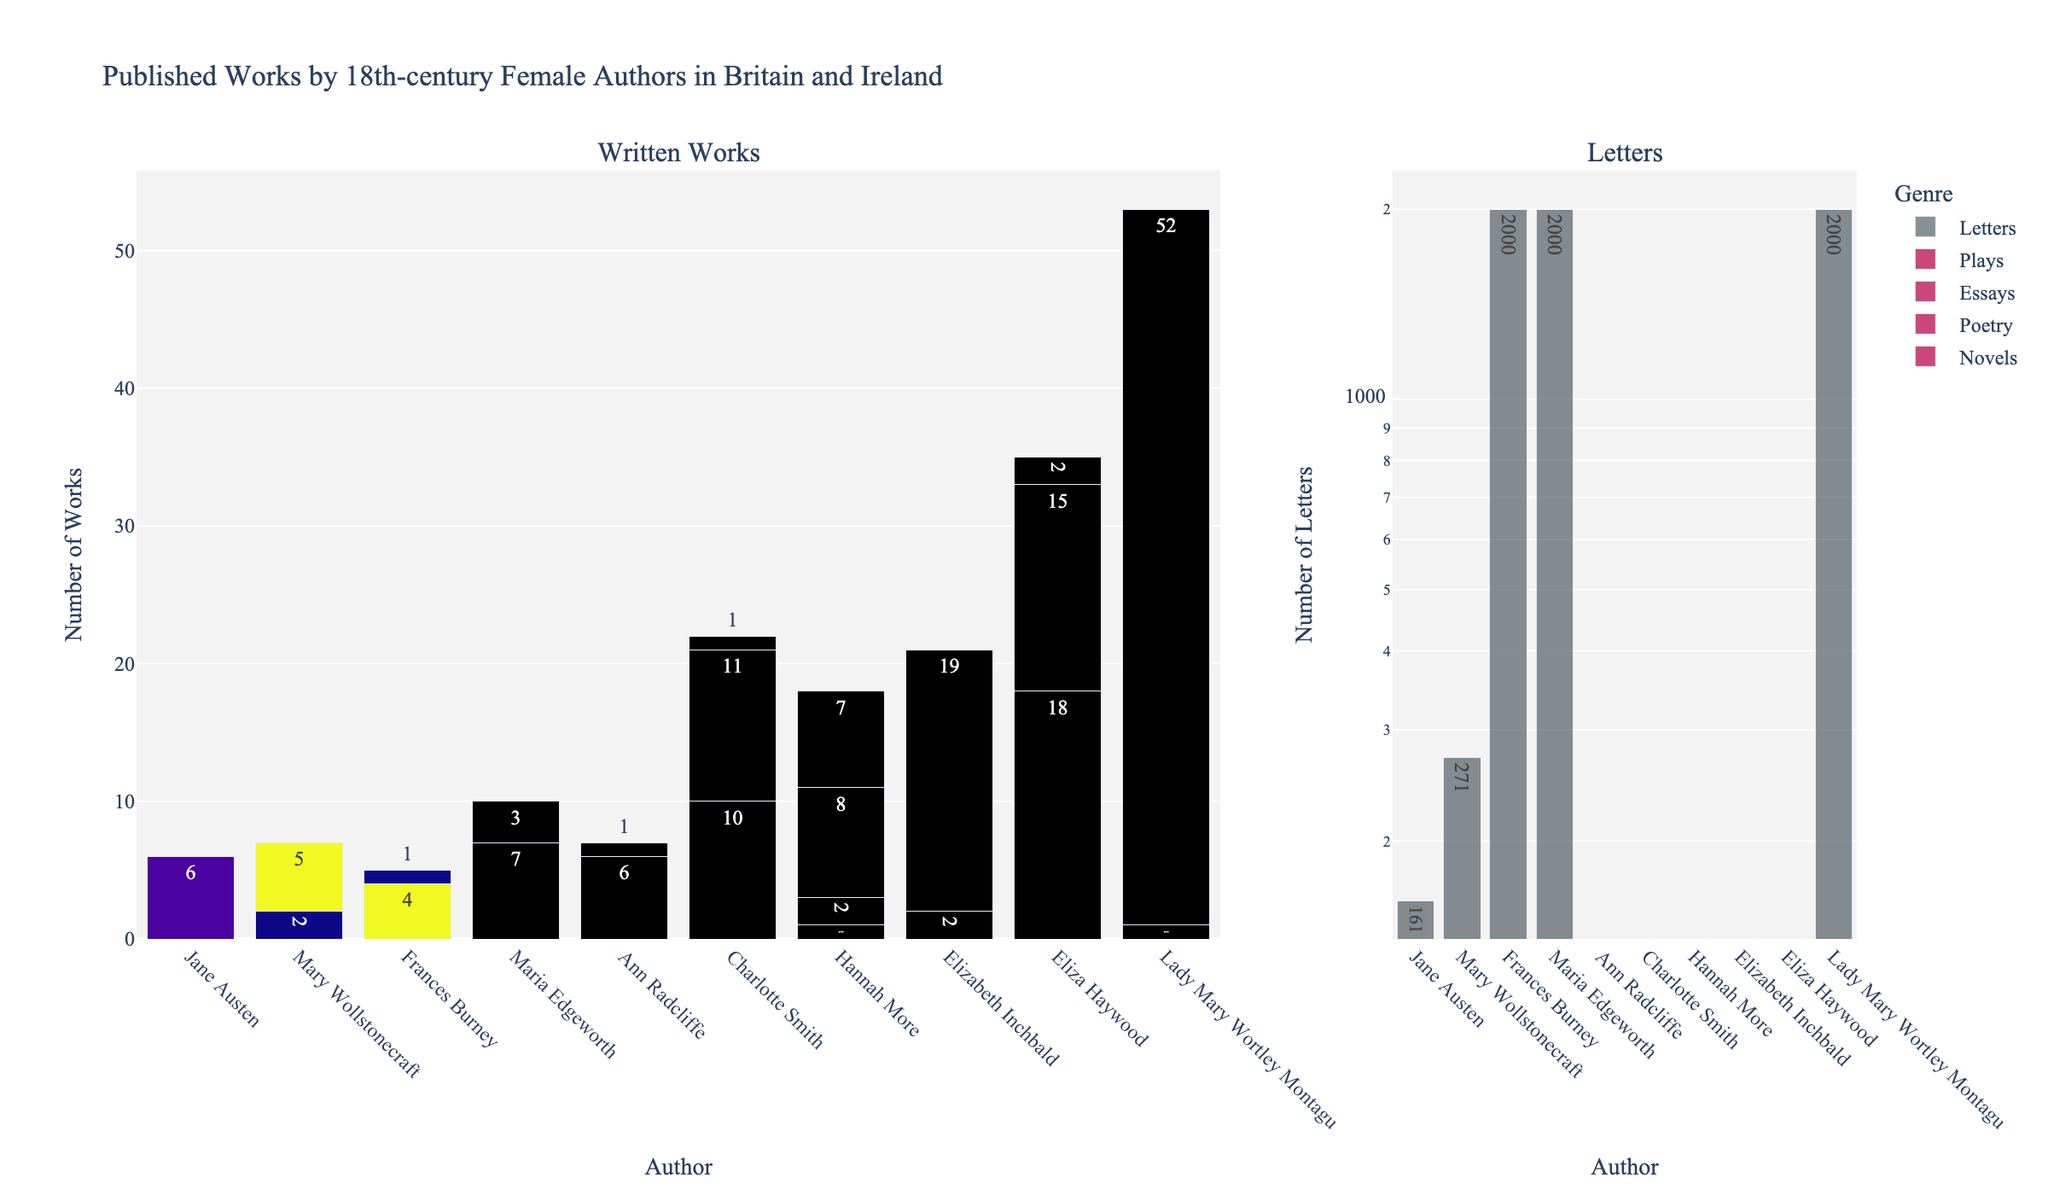What's the total number of works written by Jane Austen across all genres? Sum the number of works in each genre (Novels: 6, Poetry: 0, Essays: 0, Letters: 161, Plays: 0) for Jane Austen. 6 + 0 + 0 + 161 + 0 = 167
Answer: 167 Which author has the highest number of novels written? Compare the number of novels written by each author. Charlotte Smith has written 10 novels, which is the highest.
Answer: Charlotte Smith How many more essays did Eliza Haywood write compared to Maria Edgeworth? Subtract the number of essays written by Maria Edgeworth (3) from the number written by Eliza Haywood (15). 15 - 3 = 12
Answer: 12 Who wrote the least number of plays? Compare the number of plays written by each author. Several authors have written zero plays, including Jane Austen, Mary Wollstonecraft, Frances Burney, Maria Edgeworth, Ann Radcliffe, and Lady Mary Wortley Montagu.
Answer: Multiple authors (correct to mention any one as an answer) Which author has the second highest number of letters written? First, identify the author with the highest number of letters written (Frances Burney and Maria Edgeworth with 2000). Since they both share the highest number, we consider the second highest would be Mary Wollstonecraft with 271.
Answer: Mary Wollstonecraft Compare the number of poetry works written by Hannah More and Charlotte Smith and determine who wrote more. Hannah More wrote 2 poetry works, while Charlotte Smith wrote 11. Charlotte Smith wrote more.
Answer: Charlotte Smith What is the average number of novels written by all authors? Sum the number of novels and divide by the number of authors: (6 + 2 + 4 + 7 + 6 + 10 + 1 + 2 + 18 + 0) / 10 = 56 / 10 = 5.6
Answer: 5.6 Which genre has the fewest total works written by all authors? Sum the number of works for each genre across all authors. Poetry: 14, Novels: 56, Essays: 85, Letters: 8432, Plays: 29. Poetry has the fewest total works.
Answer: Poetry Which author's bar in the "Plays" subplot has the highest value and what is it? Check the heights of the bars in the "Plays" subplot of the chart. Elizabeth Inchbald has the highest value with 19 plays written.
Answer: Elizabeth Inchbald, 19 